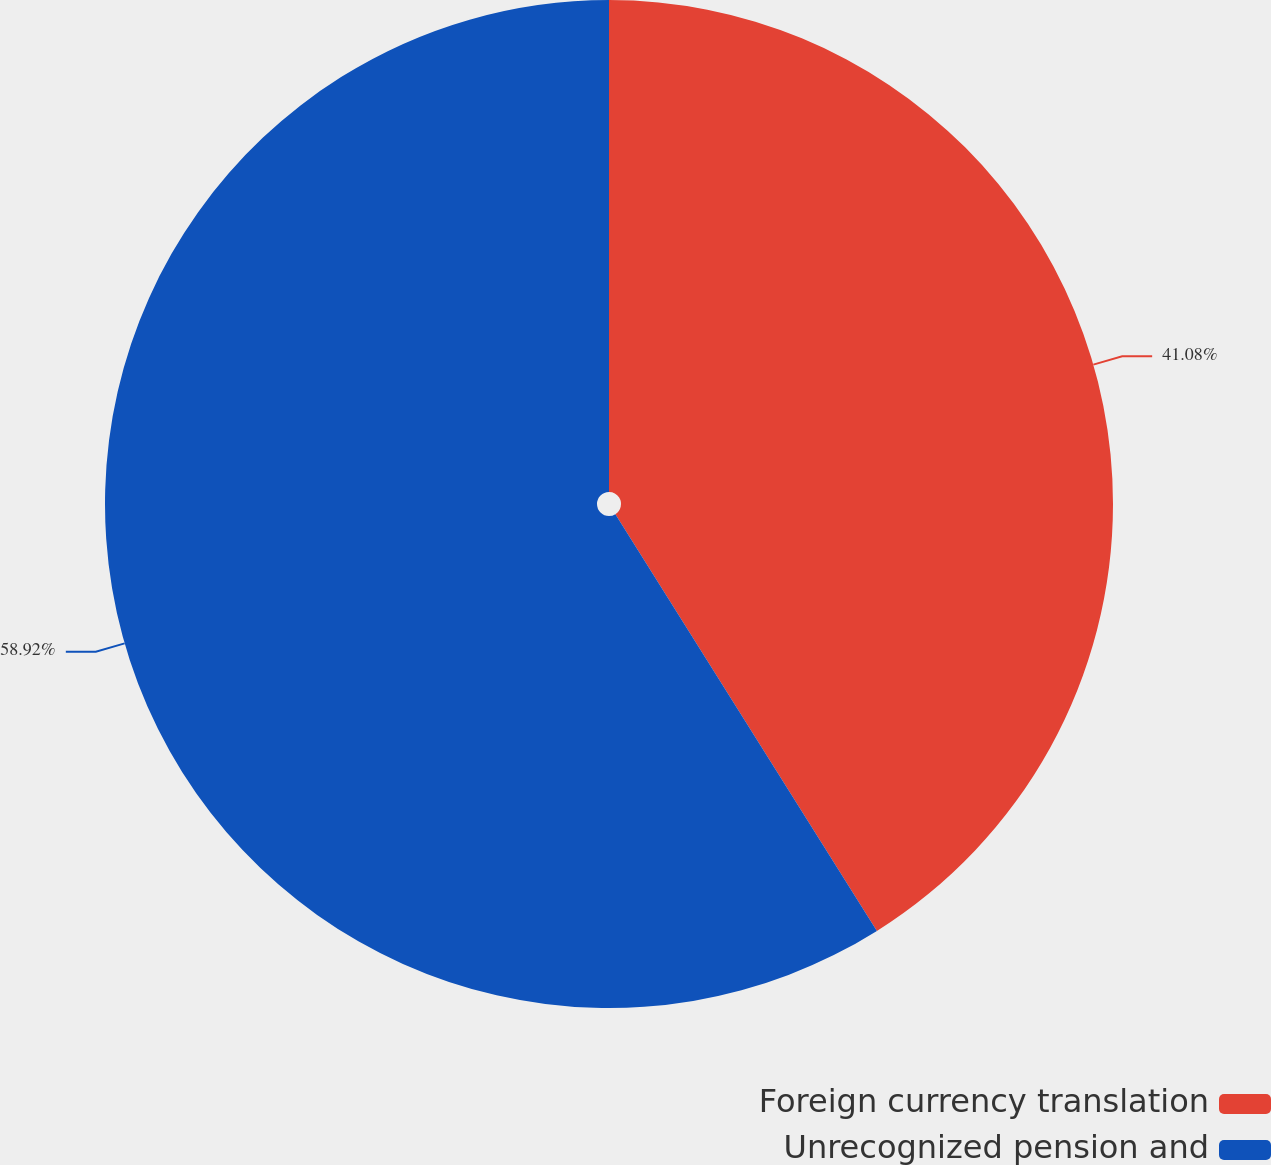Convert chart. <chart><loc_0><loc_0><loc_500><loc_500><pie_chart><fcel>Foreign currency translation<fcel>Unrecognized pension and<nl><fcel>41.08%<fcel>58.92%<nl></chart> 